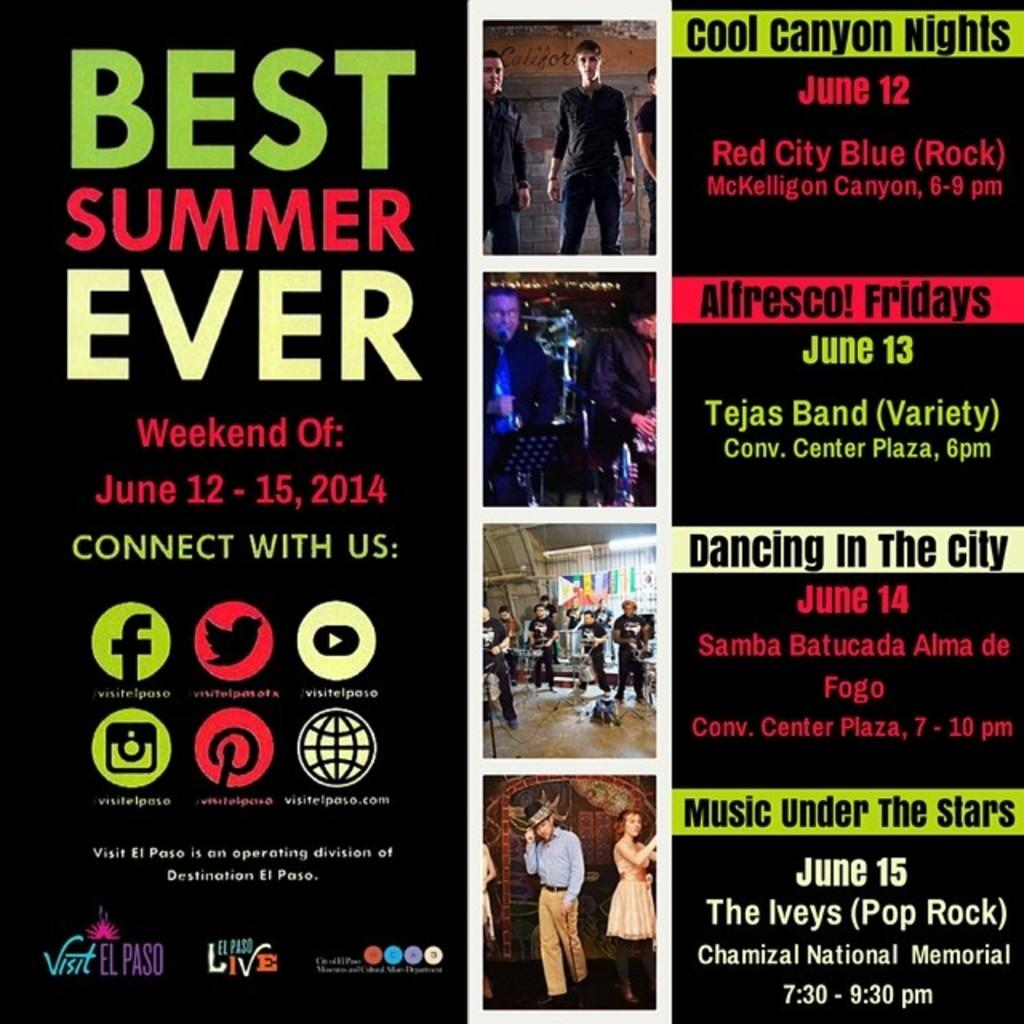What is the color of the poster in the image? The poster is black in color. What can be found on the poster besides the black background? There is text and pictures of persons on the poster. Can you describe the text on the poster? The text is in multiple colors. What type of drink is being served in the picture on the poster? There is no picture of a drink being served on the poster; it features text and pictures of persons. Can you tell me how many yams are visible in the image? There are no yams present in the image. 